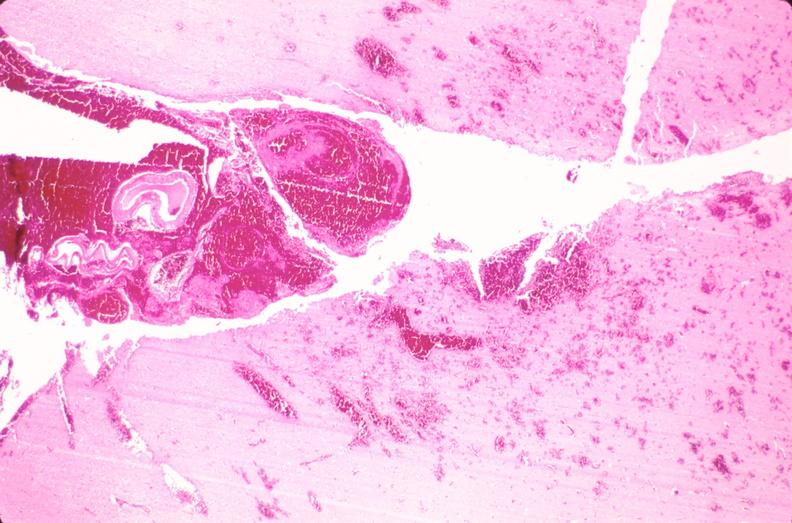why does this image show brain, subarachanoid hemorrhage and hematoma?
Answer the question using a single word or phrase. Due to ruptured aneurysm 